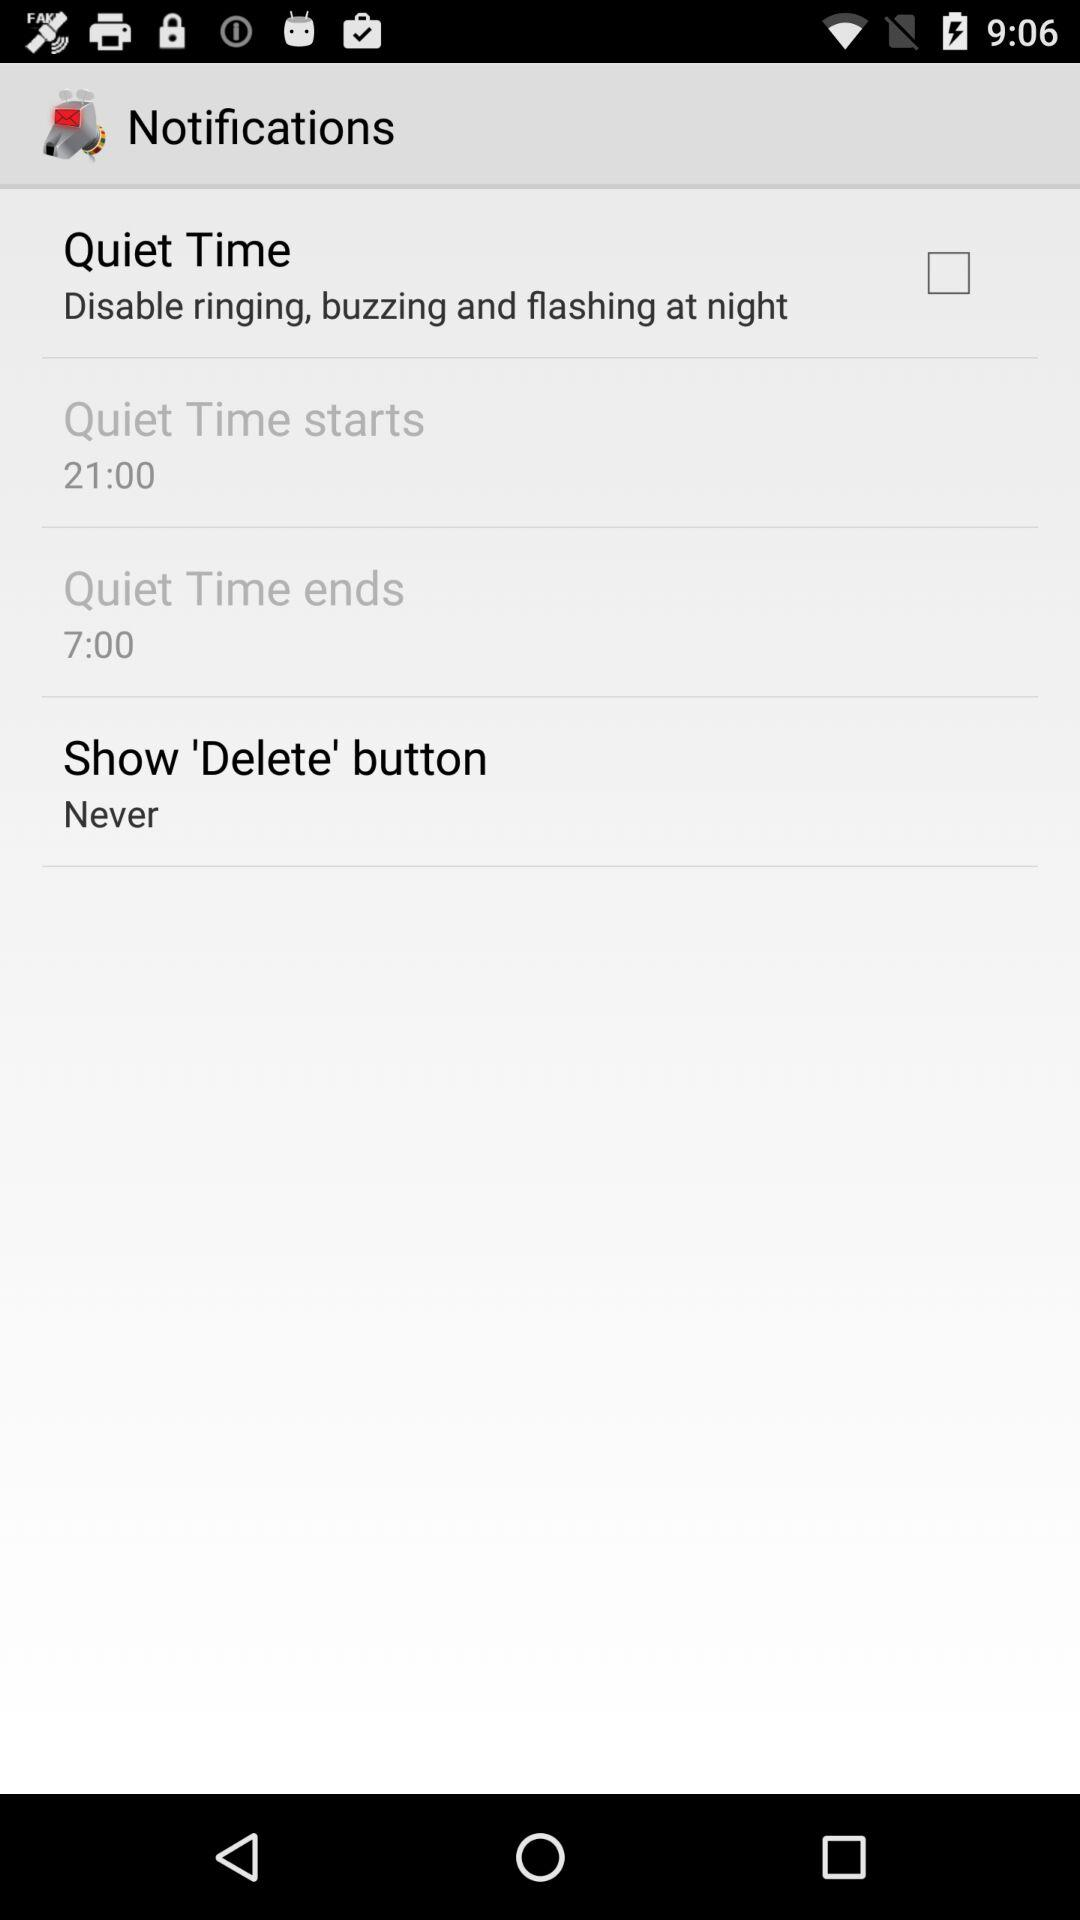When does the quiet time end? The quiet time ends at 7:00 a.m. 